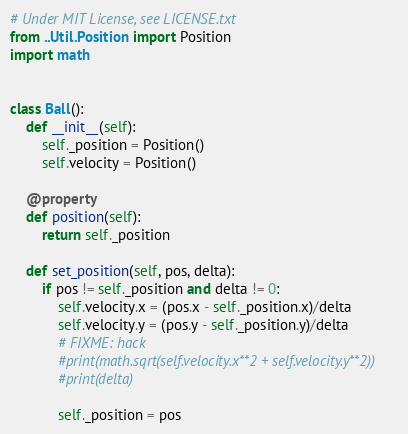<code> <loc_0><loc_0><loc_500><loc_500><_Python_># Under MIT License, see LICENSE.txt
from ..Util.Position import Position
import math


class Ball():
    def __init__(self):
        self._position = Position()
        self.velocity = Position()

    @property
    def position(self):
        return self._position

    def set_position(self, pos, delta):
        if pos != self._position and delta != 0:
            self.velocity.x = (pos.x - self._position.x)/delta
            self.velocity.y = (pos.y - self._position.y)/delta
            # FIXME: hack
            #print(math.sqrt(self.velocity.x**2 + self.velocity.y**2))
            #print(delta)

            self._position = pos</code> 